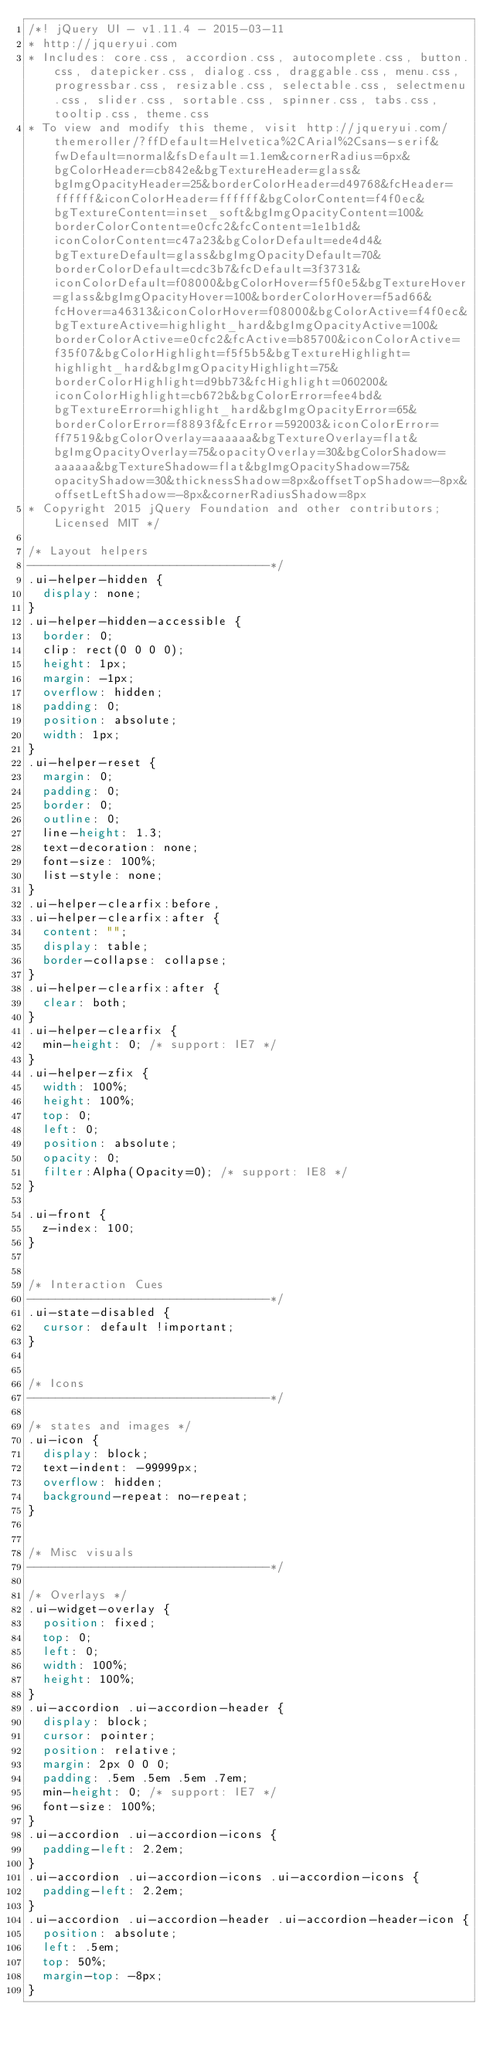Convert code to text. <code><loc_0><loc_0><loc_500><loc_500><_CSS_>/*! jQuery UI - v1.11.4 - 2015-03-11
* http://jqueryui.com
* Includes: core.css, accordion.css, autocomplete.css, button.css, datepicker.css, dialog.css, draggable.css, menu.css, progressbar.css, resizable.css, selectable.css, selectmenu.css, slider.css, sortable.css, spinner.css, tabs.css, tooltip.css, theme.css
* To view and modify this theme, visit http://jqueryui.com/themeroller/?ffDefault=Helvetica%2CArial%2Csans-serif&fwDefault=normal&fsDefault=1.1em&cornerRadius=6px&bgColorHeader=cb842e&bgTextureHeader=glass&bgImgOpacityHeader=25&borderColorHeader=d49768&fcHeader=ffffff&iconColorHeader=ffffff&bgColorContent=f4f0ec&bgTextureContent=inset_soft&bgImgOpacityContent=100&borderColorContent=e0cfc2&fcContent=1e1b1d&iconColorContent=c47a23&bgColorDefault=ede4d4&bgTextureDefault=glass&bgImgOpacityDefault=70&borderColorDefault=cdc3b7&fcDefault=3f3731&iconColorDefault=f08000&bgColorHover=f5f0e5&bgTextureHover=glass&bgImgOpacityHover=100&borderColorHover=f5ad66&fcHover=a46313&iconColorHover=f08000&bgColorActive=f4f0ec&bgTextureActive=highlight_hard&bgImgOpacityActive=100&borderColorActive=e0cfc2&fcActive=b85700&iconColorActive=f35f07&bgColorHighlight=f5f5b5&bgTextureHighlight=highlight_hard&bgImgOpacityHighlight=75&borderColorHighlight=d9bb73&fcHighlight=060200&iconColorHighlight=cb672b&bgColorError=fee4bd&bgTextureError=highlight_hard&bgImgOpacityError=65&borderColorError=f8893f&fcError=592003&iconColorError=ff7519&bgColorOverlay=aaaaaa&bgTextureOverlay=flat&bgImgOpacityOverlay=75&opacityOverlay=30&bgColorShadow=aaaaaa&bgTextureShadow=flat&bgImgOpacityShadow=75&opacityShadow=30&thicknessShadow=8px&offsetTopShadow=-8px&offsetLeftShadow=-8px&cornerRadiusShadow=8px
* Copyright 2015 jQuery Foundation and other contributors; Licensed MIT */

/* Layout helpers
----------------------------------*/
.ui-helper-hidden {
	display: none;
}
.ui-helper-hidden-accessible {
	border: 0;
	clip: rect(0 0 0 0);
	height: 1px;
	margin: -1px;
	overflow: hidden;
	padding: 0;
	position: absolute;
	width: 1px;
}
.ui-helper-reset {
	margin: 0;
	padding: 0;
	border: 0;
	outline: 0;
	line-height: 1.3;
	text-decoration: none;
	font-size: 100%;
	list-style: none;
}
.ui-helper-clearfix:before,
.ui-helper-clearfix:after {
	content: "";
	display: table;
	border-collapse: collapse;
}
.ui-helper-clearfix:after {
	clear: both;
}
.ui-helper-clearfix {
	min-height: 0; /* support: IE7 */
}
.ui-helper-zfix {
	width: 100%;
	height: 100%;
	top: 0;
	left: 0;
	position: absolute;
	opacity: 0;
	filter:Alpha(Opacity=0); /* support: IE8 */
}

.ui-front {
	z-index: 100;
}


/* Interaction Cues
----------------------------------*/
.ui-state-disabled {
	cursor: default !important;
}


/* Icons
----------------------------------*/

/* states and images */
.ui-icon {
	display: block;
	text-indent: -99999px;
	overflow: hidden;
	background-repeat: no-repeat;
}


/* Misc visuals
----------------------------------*/

/* Overlays */
.ui-widget-overlay {
	position: fixed;
	top: 0;
	left: 0;
	width: 100%;
	height: 100%;
}
.ui-accordion .ui-accordion-header {
	display: block;
	cursor: pointer;
	position: relative;
	margin: 2px 0 0 0;
	padding: .5em .5em .5em .7em;
	min-height: 0; /* support: IE7 */
	font-size: 100%;
}
.ui-accordion .ui-accordion-icons {
	padding-left: 2.2em;
}
.ui-accordion .ui-accordion-icons .ui-accordion-icons {
	padding-left: 2.2em;
}
.ui-accordion .ui-accordion-header .ui-accordion-header-icon {
	position: absolute;
	left: .5em;
	top: 50%;
	margin-top: -8px;
}</code> 